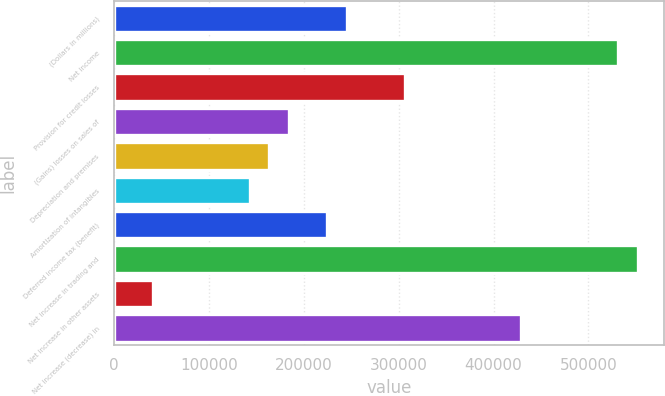Convert chart. <chart><loc_0><loc_0><loc_500><loc_500><bar_chart><fcel>(Dollars in millions)<fcel>Net income<fcel>Provision for credit losses<fcel>(Gains) losses on sales of<fcel>Depreciation and premises<fcel>Amortization of intangibles<fcel>Deferred income tax (benefit)<fcel>Net increase in trading and<fcel>Net increase in other assets<fcel>Net increase (decrease) in<nl><fcel>245361<fcel>531559<fcel>306690<fcel>184033<fcel>163591<fcel>143148<fcel>224919<fcel>552002<fcel>40934.4<fcel>429346<nl></chart> 